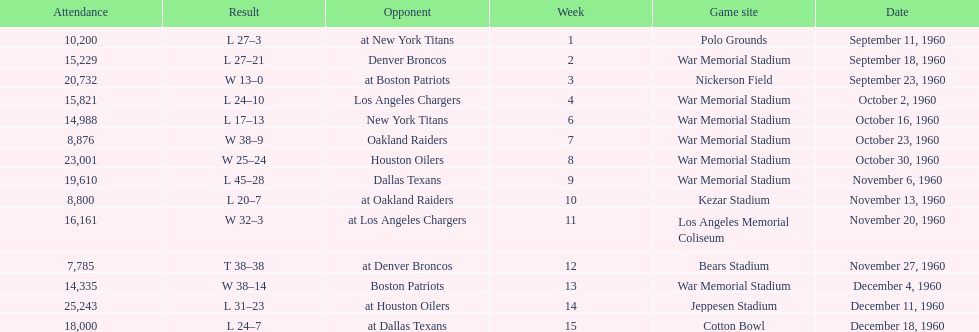Which date had the highest attendance? December 11, 1960. 